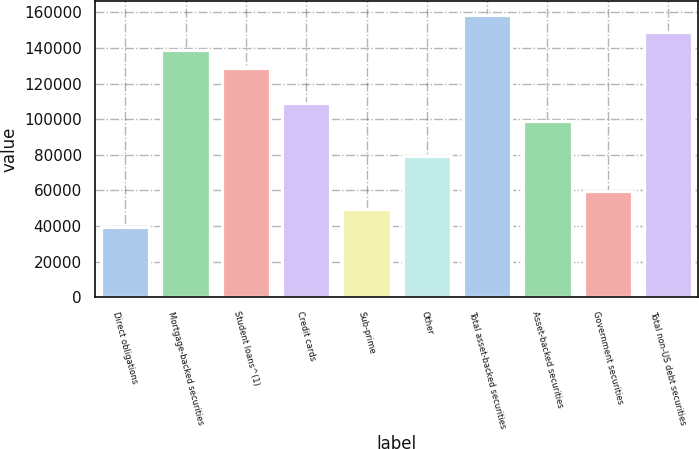Convert chart. <chart><loc_0><loc_0><loc_500><loc_500><bar_chart><fcel>Direct obligations<fcel>Mortgage-backed securities<fcel>Student loans^(1)<fcel>Credit cards<fcel>Sub-prime<fcel>Other<fcel>Total asset-backed securities<fcel>Asset-backed securities<fcel>Government securities<fcel>Total non-US debt securities<nl><fcel>39670.2<fcel>138843<fcel>128926<fcel>109091<fcel>49587.5<fcel>79339.4<fcel>158678<fcel>99174<fcel>59504.8<fcel>148760<nl></chart> 